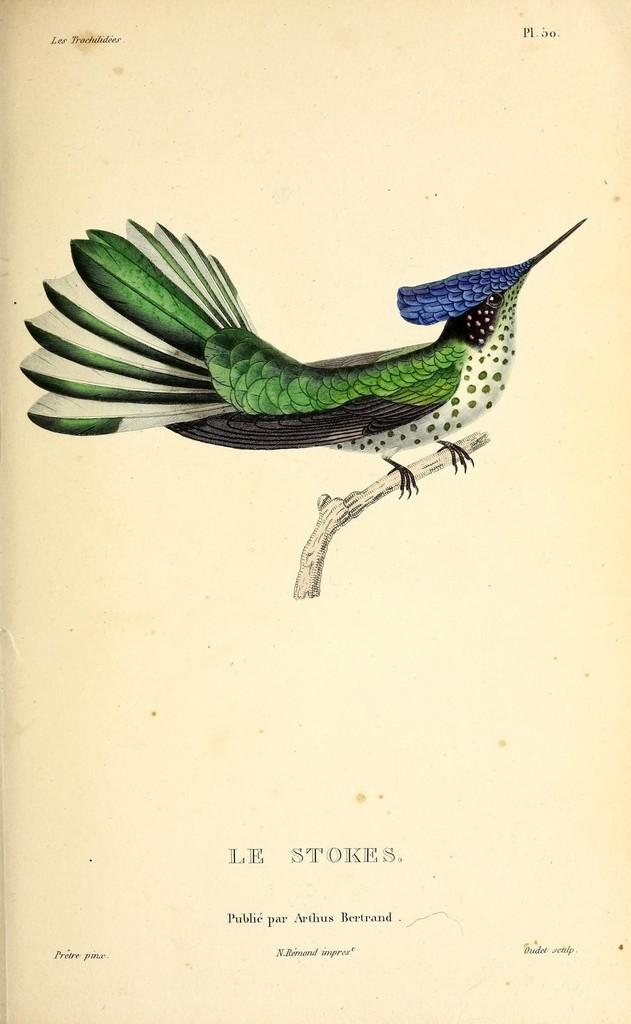What is the main subject of the poster in the image? There is a beautiful bird on the poster. Can you describe the bird's position on the poster? The bird is on a stem. What color is the background of the poster? The background of the poster is creamy. What type of punishment is the bear receiving on the roof in the image? There is no bear or roof present in the image, and therefore no such punishment can be observed. 